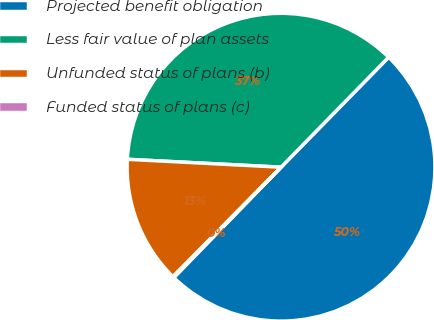Convert chart to OTSL. <chart><loc_0><loc_0><loc_500><loc_500><pie_chart><fcel>Projected benefit obligation<fcel>Less fair value of plan assets<fcel>Unfunded status of plans (b)<fcel>Funded status of plans (c)<nl><fcel>49.94%<fcel>36.51%<fcel>13.42%<fcel>0.13%<nl></chart> 